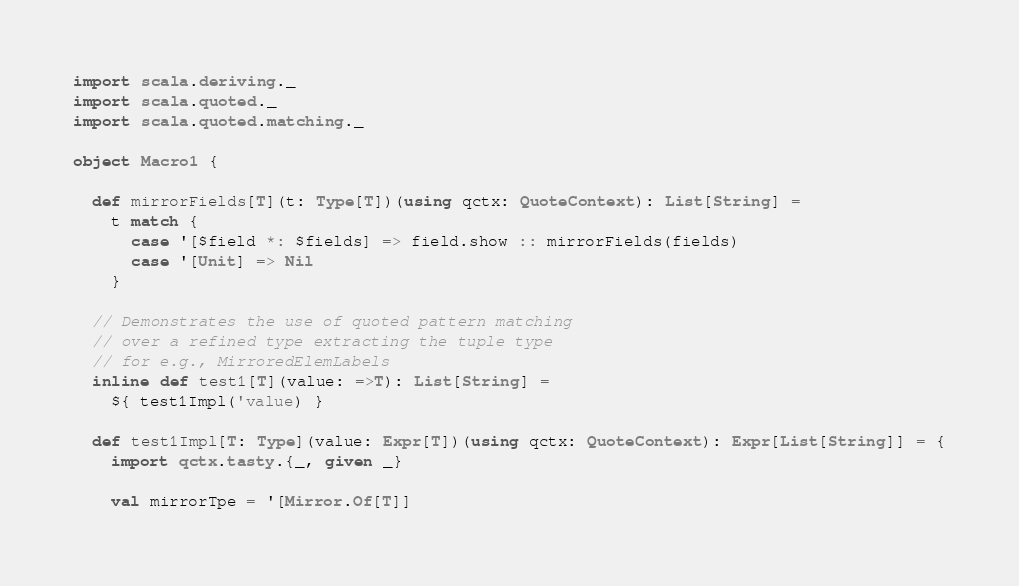Convert code to text. <code><loc_0><loc_0><loc_500><loc_500><_Scala_>import scala.deriving._
import scala.quoted._
import scala.quoted.matching._

object Macro1 {

  def mirrorFields[T](t: Type[T])(using qctx: QuoteContext): List[String] =
    t match {
      case '[$field *: $fields] => field.show :: mirrorFields(fields)
      case '[Unit] => Nil
    }

  // Demonstrates the use of quoted pattern matching
  // over a refined type extracting the tuple type
  // for e.g., MirroredElemLabels
  inline def test1[T](value: =>T): List[String] =
    ${ test1Impl('value) }

  def test1Impl[T: Type](value: Expr[T])(using qctx: QuoteContext): Expr[List[String]] = {
    import qctx.tasty.{_, given _}

    val mirrorTpe = '[Mirror.Of[T]]
</code> 